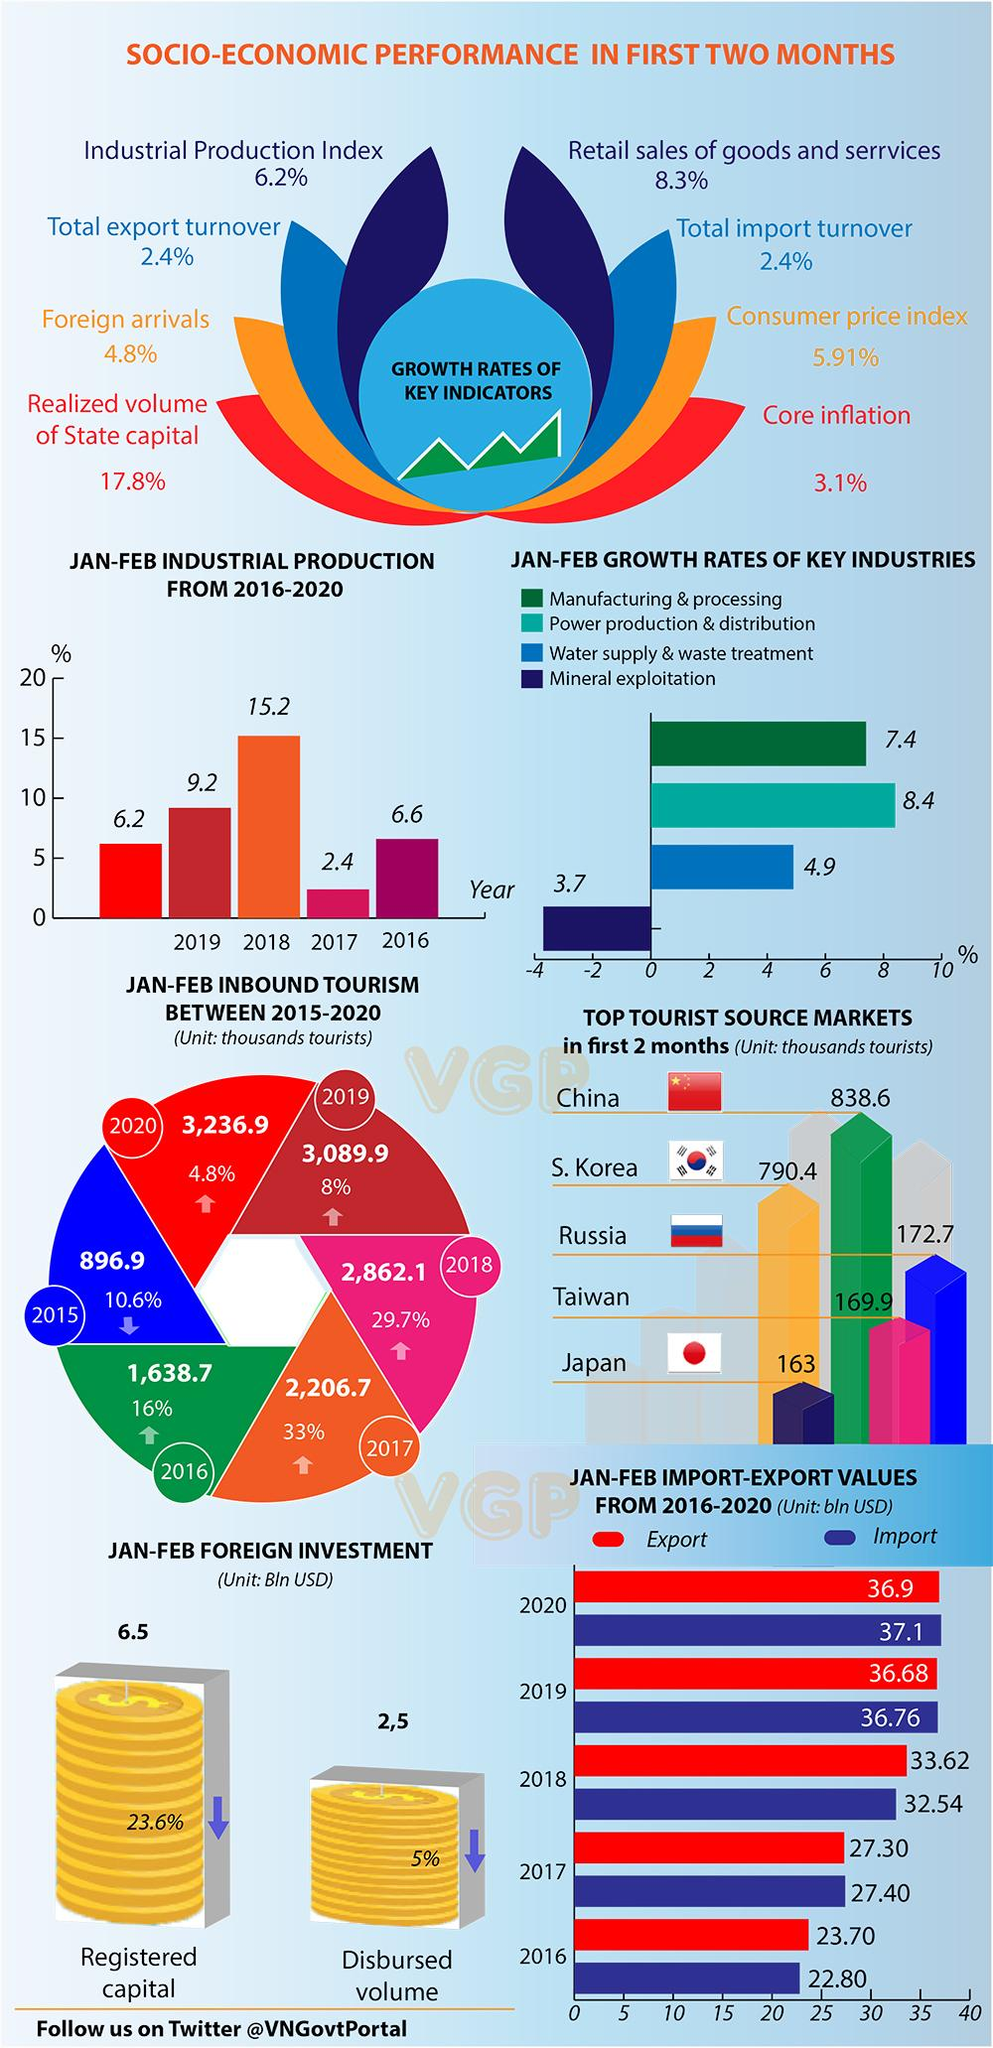Specify some key components in this picture. The growth rate of the water supply and waste treatment industry in the first two months of 2016-2020 was 4.9%. The import value in the first two months of 2020 was 37.1 billion USD. During the period of 2016-2020, the industrial production rate marked the lowest in the month of January-February in 2017. During the period of 2016-2020, the power production and distribution industry demonstrated the highest growth rate in the first two months. In the first two months of 2016, the import value was 22.80 billion USD. 